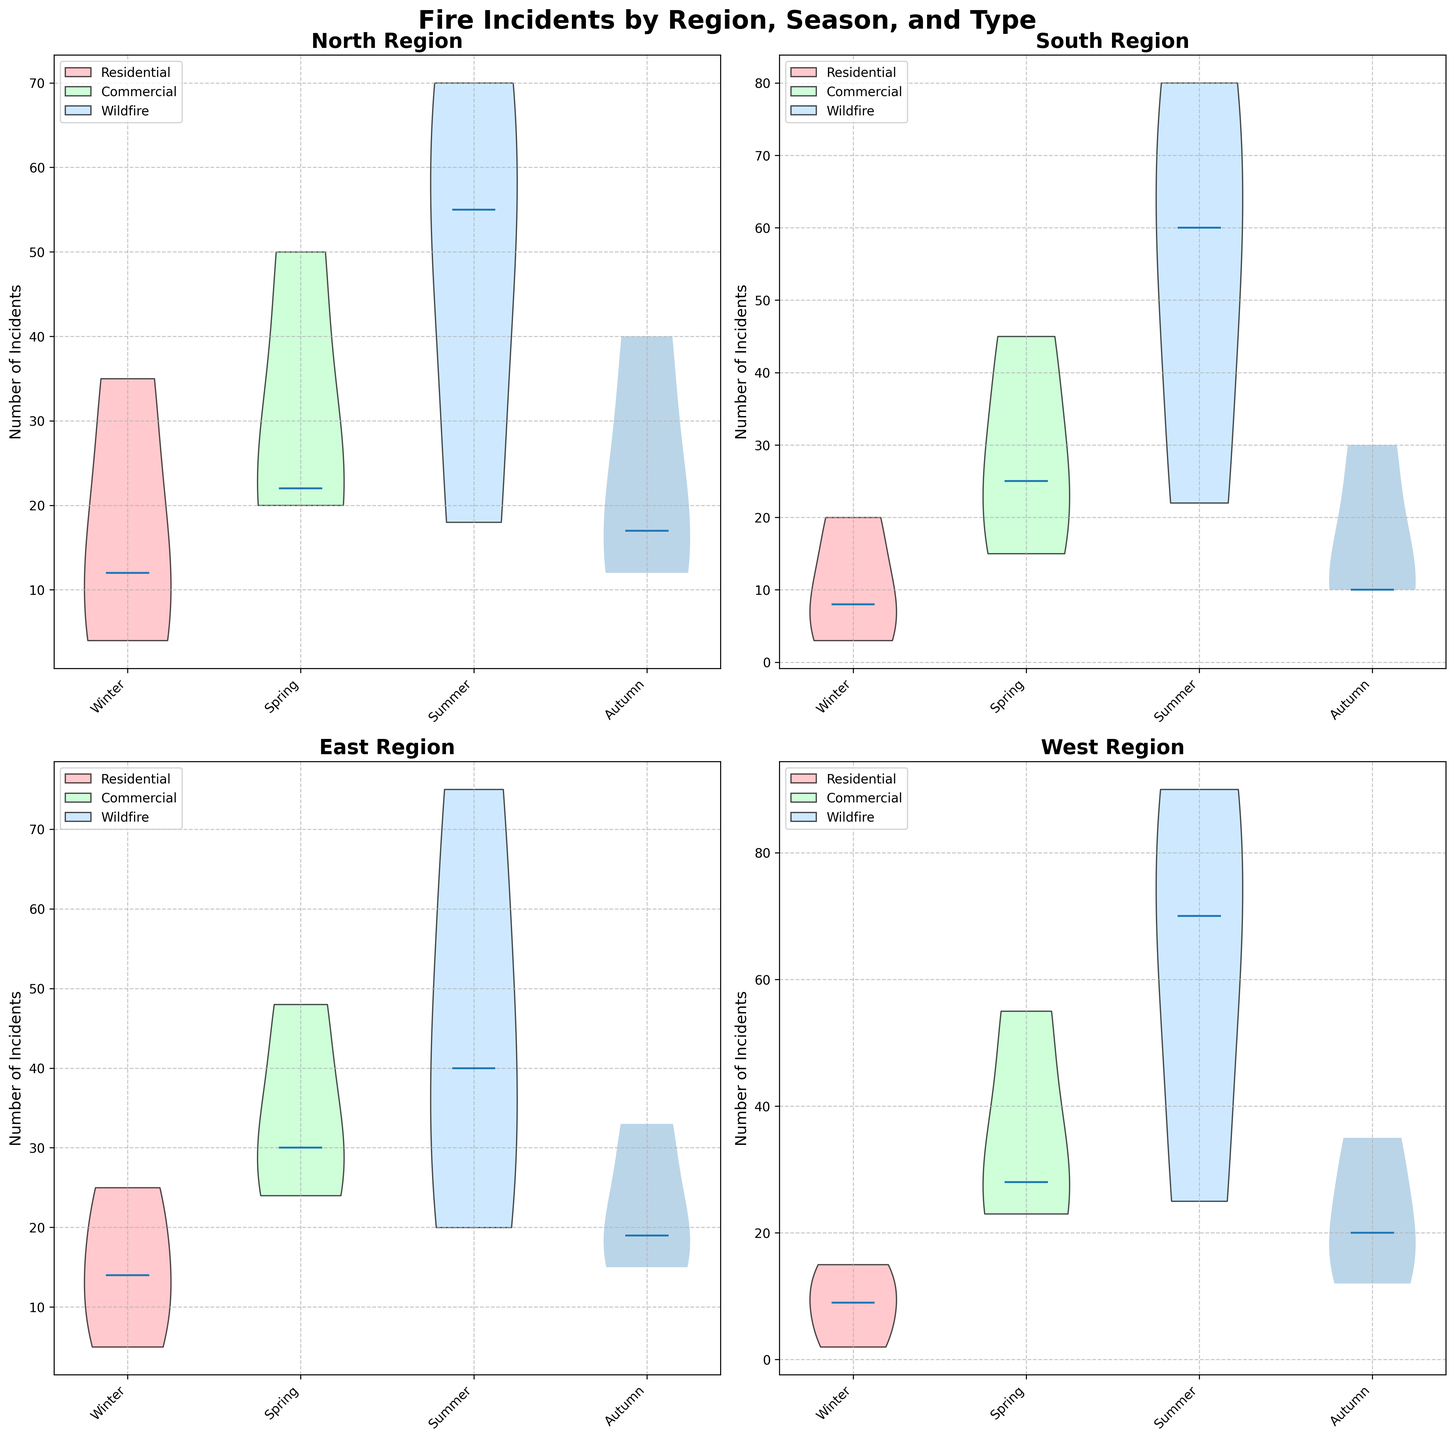How many total regions are depicted in the figure? The figure shows violins for different regions classified by season and fire type, summing up to four regions: North, South, East, and West.
Answer: Four Which region has the most incidents of wildfire in the Summer? By comparing the violins for wildfire in the summer across all the regions, the West region shows the highest value.
Answer: West What is the general trend in the number of residential fire incidents from Winter to Summer in the North? Observing the violins for residential fire incidents in the North from Winter to Summer, there is an increasing trend: Winter<Spring<Summer.
Answer: Increasing Calculate the difference in the number of Commercial fire incidents between Spring and Autumn in the East region. The East region's violin chart for commercial fires in Spring is higher than in Autumn. The exact values from the data are 24 in Spring and 19 in Autumn, so the difference is 24 - 19 = 5.
Answer: 5 When do the South region and North region both have the lowest median number of wildfire incidents? The lowest median number of wildfire incidents for both South and North regions occur in Winter. According to the data, both regions have their lowest wildfire incidents in Winter (3 for South, 4 for North).
Answer: Winter Compare the number of Residential fire incidents in Autumn between East and West regions. The violin plots show the East region has a lower number than the West. The exact data counts confirm it with 33 for East and 35 for West.
Answer: West Which season appears to have the least variation in the number of incidents for Commercial fires in the South region? Observing the spread of violins for South region commercial fires, Winter shows the least variation compared to the other seasons.
Answer: Winter What can be inferred about the risk patterns of wildfires for the East region through the seasons? From the violin plots, we can observe an increasing pattern from Winter to Summer, peaking in Summer and decreasing in Autumn.
Answer: Summer peak 